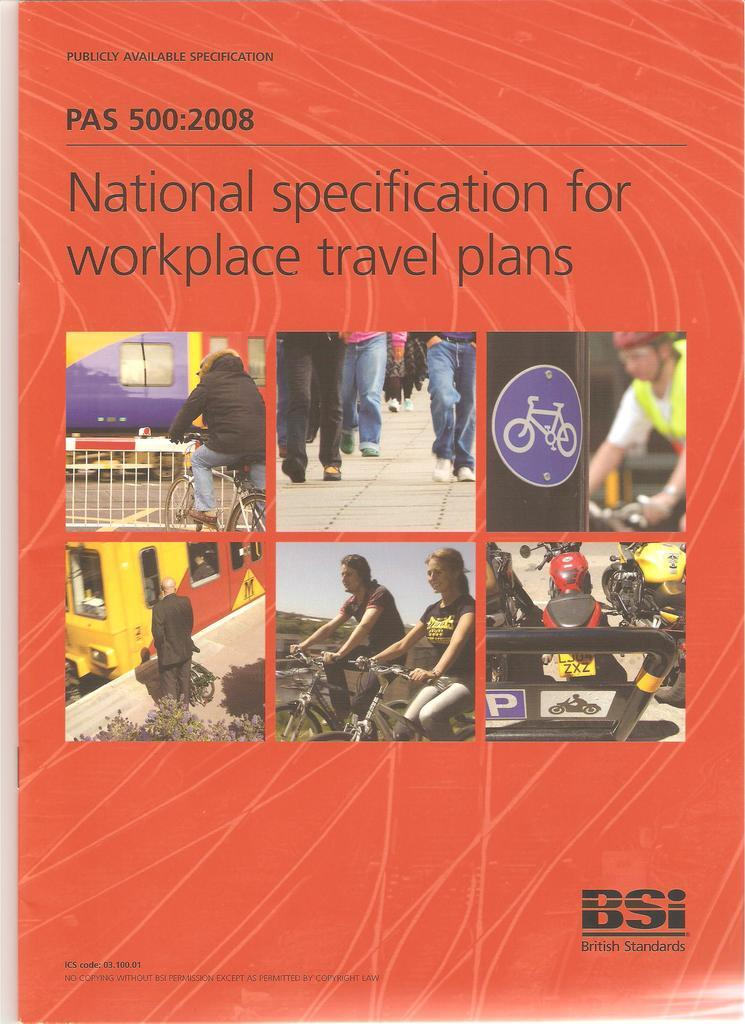What is the main object in the image? There is a paper in the image. What are the people in the image doing on the paper? There are persons walking on the paper and standing in front of a yellow color bus on the paper. What can be seen in the background of the paper? There is a yellow color bus visible on the paper. What is written or printed on the paper? There is text visible on the paper. What type of milk is being poured on the seed in the image? There is no milk or seed present in the image; it features a paper with people and a bus. 